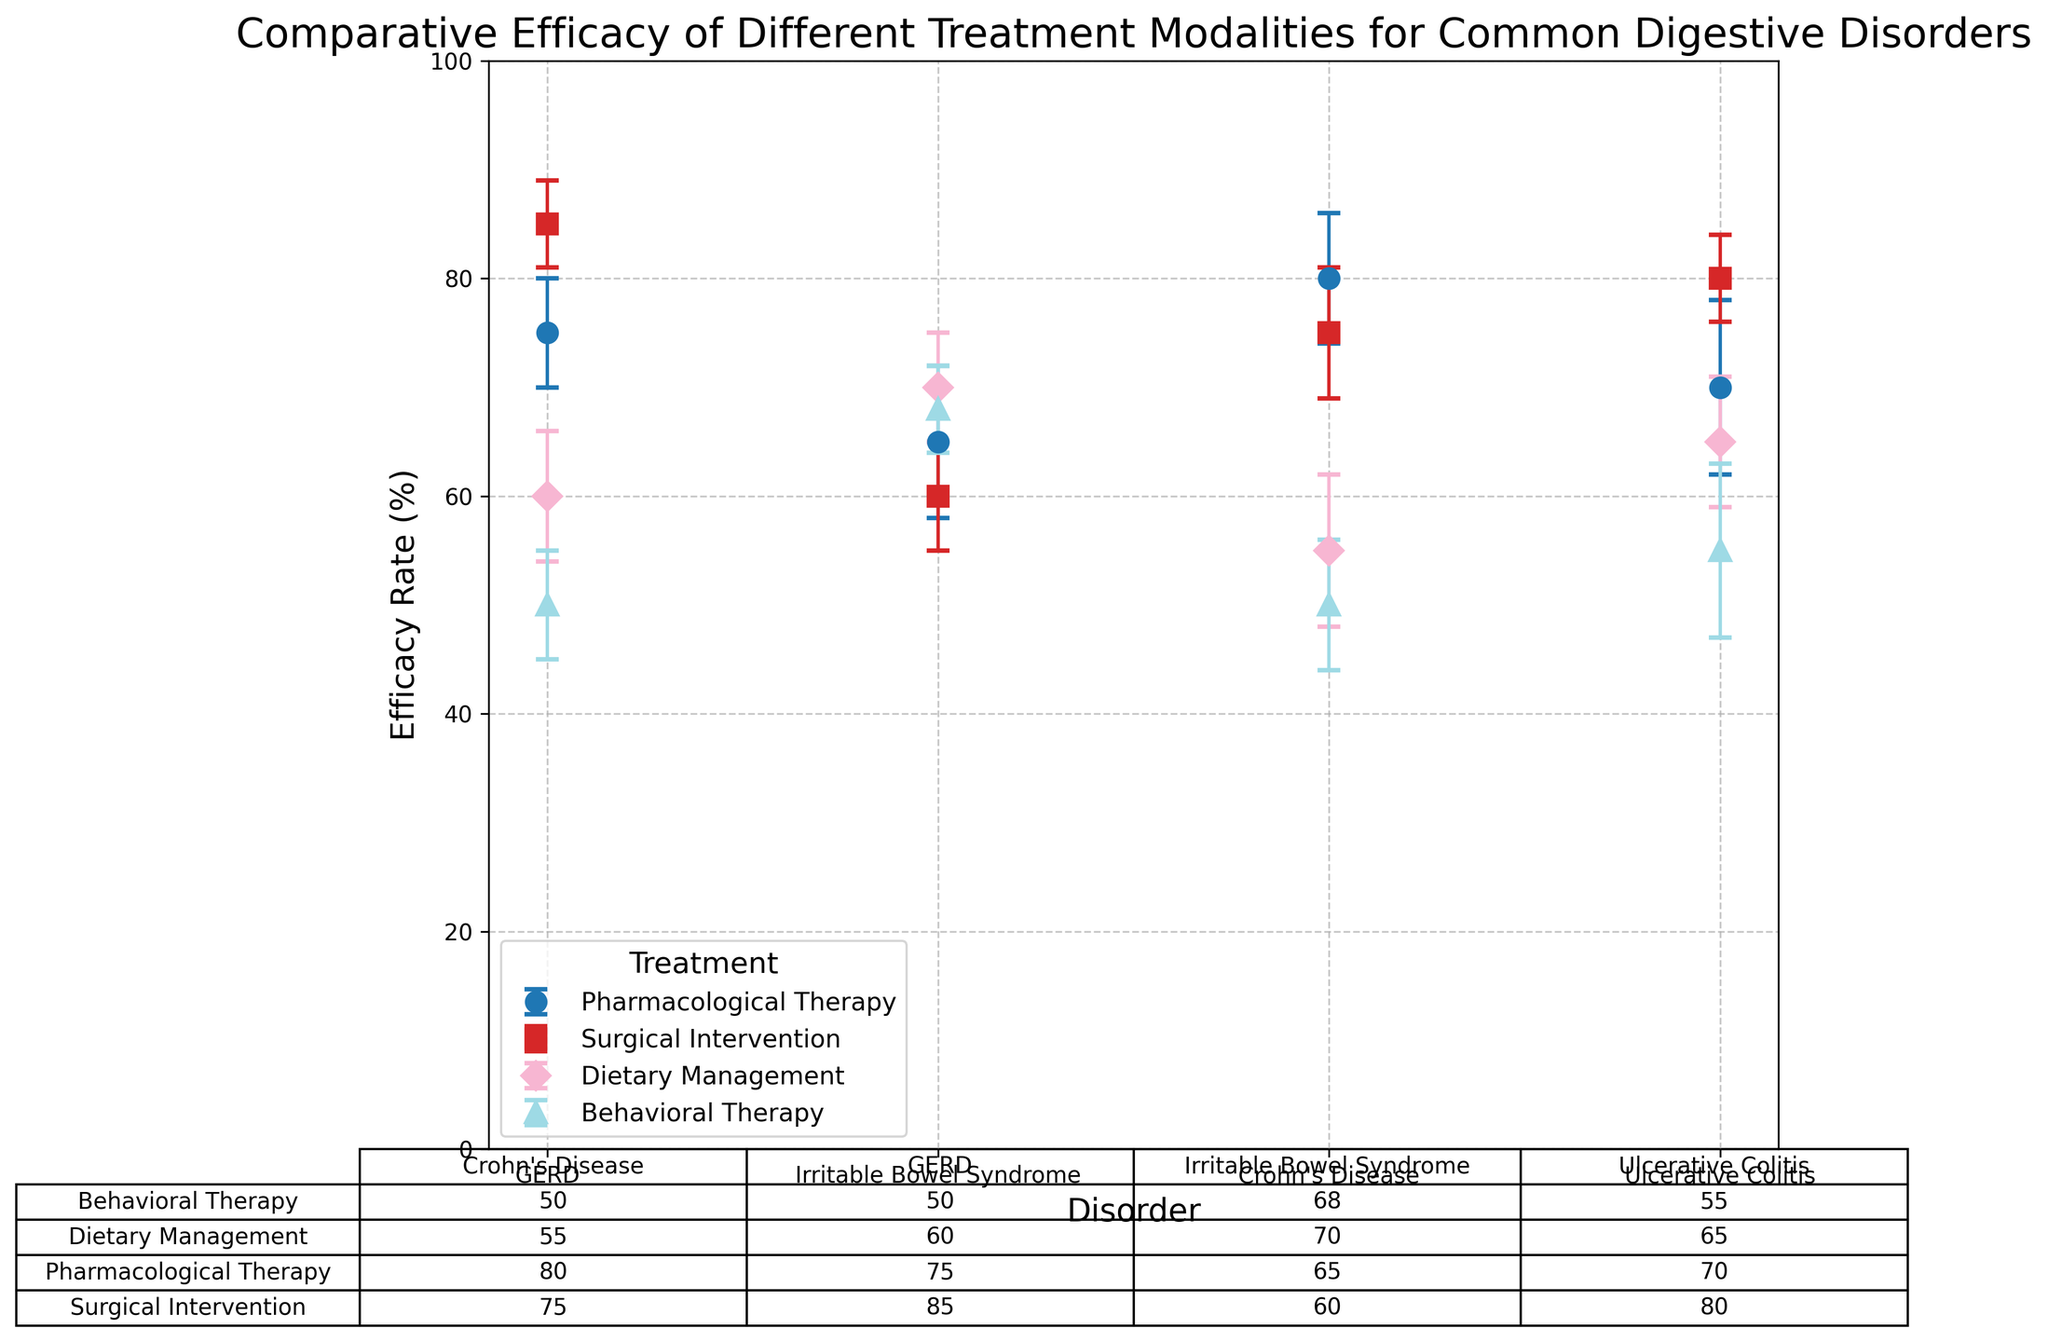Which treatment has the highest efficacy rate for GERD? Check the figure and find the treatment with the highest efficacy rate along with the label for GERD. According to the plot, Surgical Intervention has the highest efficacy rate for GERD.
Answer: Surgical Intervention Compare the efficacy rates of Pharmacological Therapy and Behavioral Therapy for Irritable Bowel Syndrome. Which one is higher and by how much? From the figure, find the efficacy rates for Pharmacological Therapy and Behavioral Therapy for Irritable Bowel Syndrome. Pharmacological Therapy has an efficacy rate of 65%, while Behavioral Therapy has an efficacy rate of 68%. Subtract the former from the latter: 68% - 65% = 3%.
Answer: Behavioral Therapy, 3% Which disorder has the most variation in efficacy rates across different treatments? Look at the error bars representing standard deviation. The disorder with the most variation will have the widest range of efficacy rates. Upon inspection, Ulcerative Colitis has a wide range, from 55% (Behavioral Therapy) to 80% (Surgical Intervention).
Answer: Ulcerative Colitis What is the average efficacy rate across all treatments for Crohn's Disease? Extract the efficacy rates for Crohn's Disease: 80 (Pharmacological Therapy), 75 (Surgical Intervention), 55 (Dietary Management), 50 (Behavioral Therapy). Add them up and divide by the number of treatments: (80 + 75 + 55 + 50) / 4 = 65%.
Answer: 65% Which treatment modality has the most consistent (least variable) efficacy rates across all disorders? Consider the standard deviation (error bars) for each treatment modality. The treatment with the smallest average standard deviation is Surgical Intervention, which generally has smaller error bars compared to others.
Answer: Surgical Intervention Among the different treatment modalities, which one yields the lowest efficacy rate for any disorder? Specify the disorder and the rate. Identify the lowest efficacy rate across all treatments and disorders. Behavioral Therapy for Crohn's Disease and GERD both have the lowest efficacy rate at 50%.
Answer: Behavioral Therapy, Crohn's Disease/GERD, 50% Compare the efficacy rates of Dietary Management and Surgical Intervention for Ulcerative Colitis. Which one is higher and by how much? Look at the figure to find the efficacy rates of Dietary Management and Surgical Intervention for Ulcerative Colitis. Dietary Management is 65%, while Surgical Intervention is 80%. Subtract the former from the latter: 80% - 65% = 15%.
Answer: Surgical Intervention, 15% Which treatment modality for GERD shows the largest difference in efficacy rates when comparing the highest and lowest rates? Compare the efficacy rates of all treatment modalities for GERD. Surgical Intervention (85%) vs Behavioral Therapy (50%) shows the largest difference. Calculate the difference: 85% - 50% = 35%.
Answer: Surgical Intervention and Behavioral Therapy, 35% What is the sum of the efficacy rates of all treatments for Irritable Bowel Syndrome? Extract the efficacy rates for each treatment: Pharmacological Therapy (65), Surgical Intervention (60), Dietary Management (70), Behavioral Therapy (68). Add them up: 65 + 60 + 70 + 68 = 263.
Answer: 263% Which treatment has the highest standard deviation in efficacy rates across all disorders? Examine the figure and identify the treatment with the highest standard deviation. Pharmacological Therapy for Ulcerative Colitis has the highest standard deviation of 8%.
Answer: Pharmacological Therapy 